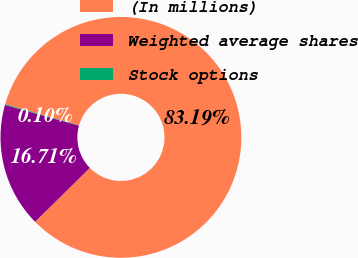<chart> <loc_0><loc_0><loc_500><loc_500><pie_chart><fcel>(In millions)<fcel>Weighted average shares<fcel>Stock options<nl><fcel>83.19%<fcel>16.71%<fcel>0.1%<nl></chart> 